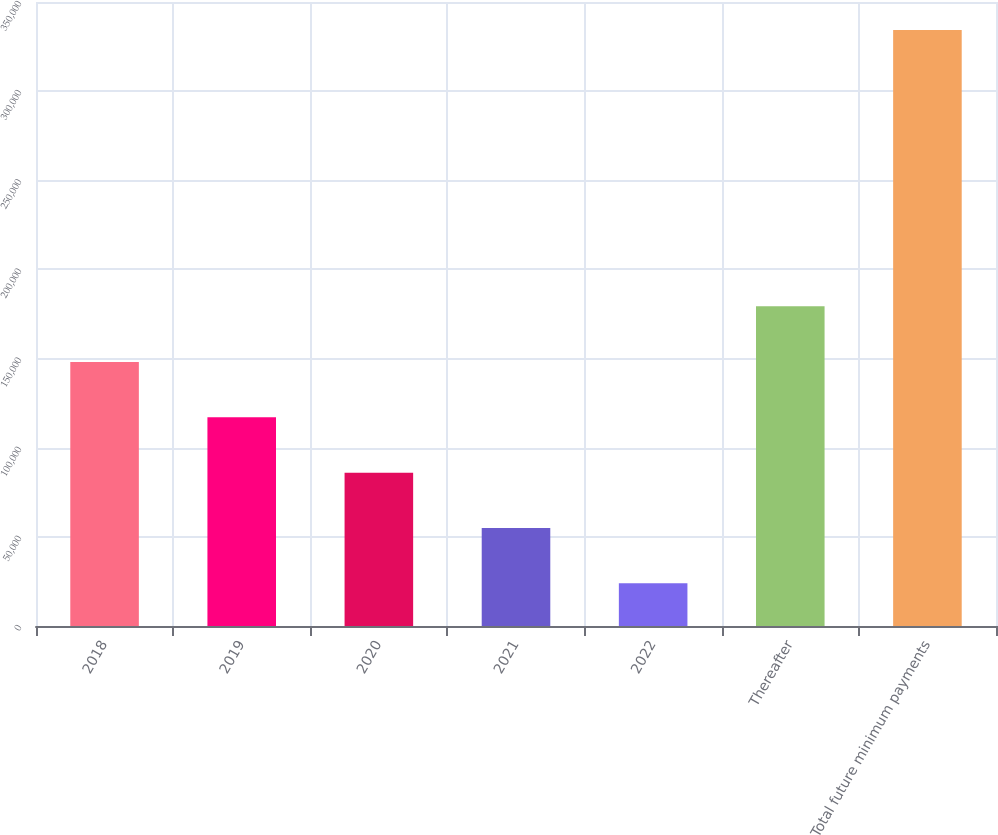Convert chart. <chart><loc_0><loc_0><loc_500><loc_500><bar_chart><fcel>2018<fcel>2019<fcel>2020<fcel>2021<fcel>2022<fcel>Thereafter<fcel>Total future minimum payments<nl><fcel>148081<fcel>117047<fcel>86013.6<fcel>54979.8<fcel>23946<fcel>179295<fcel>334284<nl></chart> 